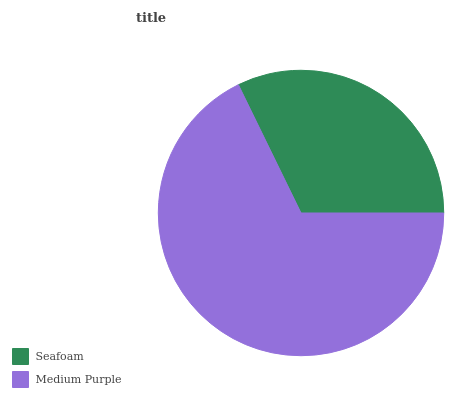Is Seafoam the minimum?
Answer yes or no. Yes. Is Medium Purple the maximum?
Answer yes or no. Yes. Is Medium Purple the minimum?
Answer yes or no. No. Is Medium Purple greater than Seafoam?
Answer yes or no. Yes. Is Seafoam less than Medium Purple?
Answer yes or no. Yes. Is Seafoam greater than Medium Purple?
Answer yes or no. No. Is Medium Purple less than Seafoam?
Answer yes or no. No. Is Medium Purple the high median?
Answer yes or no. Yes. Is Seafoam the low median?
Answer yes or no. Yes. Is Seafoam the high median?
Answer yes or no. No. Is Medium Purple the low median?
Answer yes or no. No. 